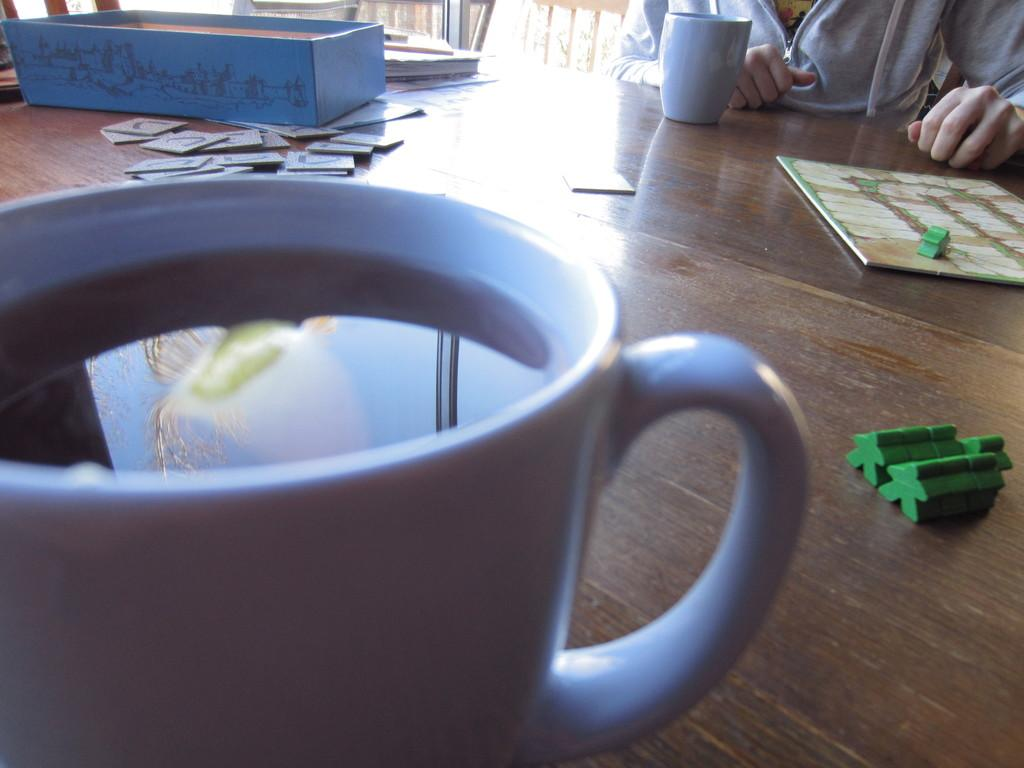What is in the tea cup that is visible in the image? There is liquid in the tea cup in the image. Where is the tea cup located? The tea cup is on a table in the image. What else can be seen on the table? There are other objects on the table in the image. Who is present in the image? A person is sitting in front of the table in the image. Can be seen in the plantation in the image? There is no mention of a plantation or ducks in the image. 